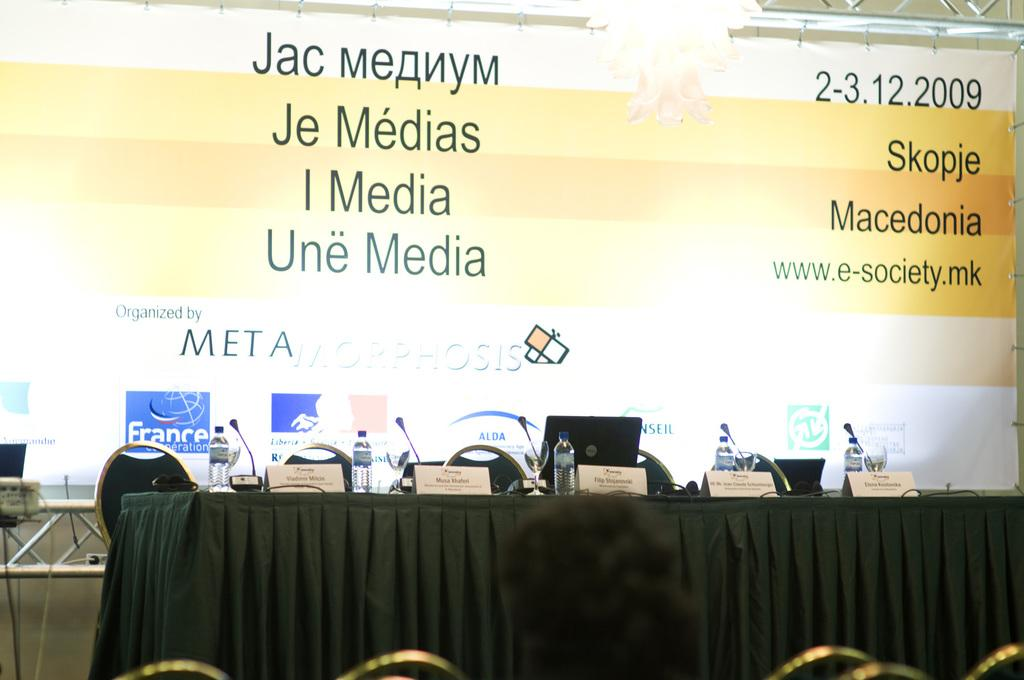What type of furniture is present in the image? There are chairs in the image. What can be seen on the table in the image? There are water bottles and microphones on the table in the image. What is displayed on the wall in the image? There is a hoarding on the wall in the image. Are there any dinosaurs visible in the image? No, there are no dinosaurs present in the image. What type of knowledge can be gained from the hoarding in the image? The hoarding in the image is not a source of knowledge; it is an advertisement or display. 